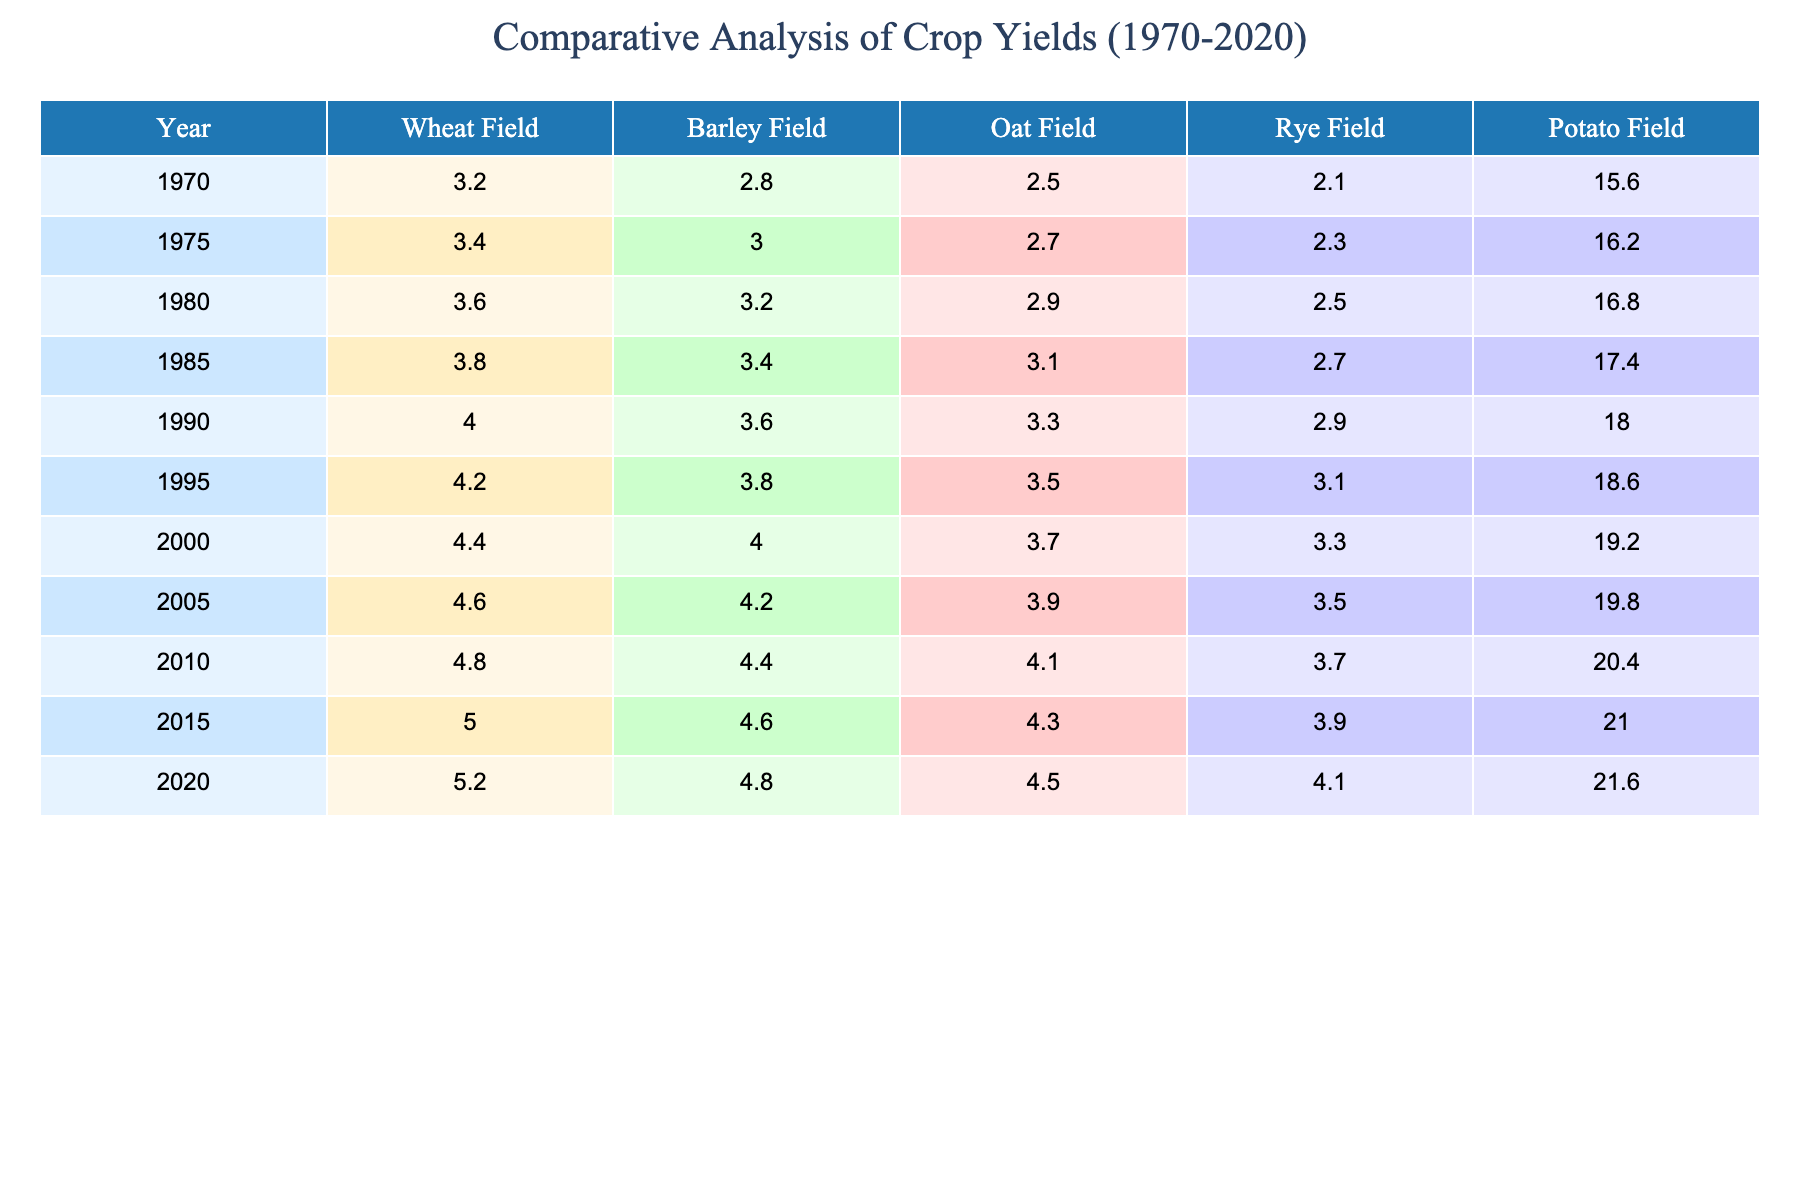What was the yield of wheat in 2010? According to the table data, the yield of wheat for the year 2010 is directly referenced, which shows it to be 4.8 tons per hectare.
Answer: 4.8 Which crop had the highest yield in the year 2020? The table lists the crop yields for various fields in 2020. By comparing the values, the yield for the potato field in 2020 is 21.6 tons per hectare, which is higher than all other crops.
Answer: Potato Field What is the difference in oat yield between 1995 and 2000? The oat yields for 1995 and 2000 are 3.5 and 3.7 tons per hectare respectively. Subtracting 3.5 from 3.7 gives a difference of 0.2 tons per hectare.
Answer: 0.2 What was the average yield of barley from 1970 to 2020? First, I will sum the barley yields over the years: (2.8 + 3.0 + 3.2 + 3.4 + 3.6 + 3.8 + 4.0 + 4.2 + 4.4 + 4.6 + 4.8) = 40.8. There are 11 data points (years), thus the average yield is 40.8 / 11 = approximately 3.709 tons per hectare.
Answer: 3.709 In which year was the wheat yield the lowest, and what was that yield? Upon reviewing the table, the lowest yield for wheat can be found in 1970, where the yield is 3.2 tons per hectare.
Answer: 1970, 3.2 Did the rye yield ever exceed 4 tons per hectare from 1970 to 2020? Referring to the rye yields provided in the table, it shows yields below 4 tons per hectare for all listed years until 2020, where it is exactly 4.1 tons. This indicates it did not exceed 4 tons prior to 2020.
Answer: No What is the total yield of potatoes from 1970 to 2020? To find the total yield of potatoes, I will add all of the potato yields: (15.6 + 16.2 + 16.8 + 17.4 + 18.0 + 18.6 + 19.2 + 19.8 + 20.4 + 21.0 + 21.6) =  205.6 tons per hectare.
Answer: 205.6 Which crop showed the greatest increase in yield from 1970 to 2020? Observing the crop yields in the years 1970 (3.2 for wheat), (2.8 for barley), (2.5 for oat), (2.1 for rye), and (15.6 for potato) and comparing them with the yields in 2020, the potato field increased from 15.6 to 21.6, which is an increase of 6 tons. This is the largest increase among all crops studied.
Answer: Potato Field How many crops had a yield of 4 tons or more in 2015? From the data in 2015, the wheat field yielded 5.0, barley 4.6, oat 4.3, and rye 3.9. Thus, wheat, barley, and oat had yields of 4 tons or more, totaling 3 crops.
Answer: 3 What was the trend in wheat yield from 1970 to 2020? Analyzing the values over the years: the wheat yield shows a consistent increase from 3.2 in 1970 to 5.2 in 2020 indicating a positive trend in yield over this 50-year period.
Answer: Increasing 